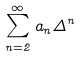Convert formula to latex. <formula><loc_0><loc_0><loc_500><loc_500>\sum _ { n = 2 } ^ { \infty } a _ { n } \Delta ^ { n }</formula> 